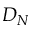<formula> <loc_0><loc_0><loc_500><loc_500>D _ { N }</formula> 